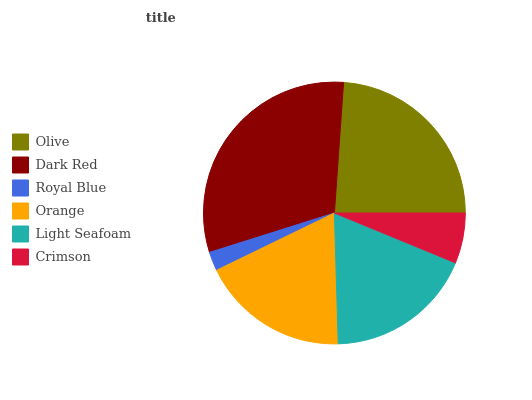Is Royal Blue the minimum?
Answer yes or no. Yes. Is Dark Red the maximum?
Answer yes or no. Yes. Is Dark Red the minimum?
Answer yes or no. No. Is Royal Blue the maximum?
Answer yes or no. No. Is Dark Red greater than Royal Blue?
Answer yes or no. Yes. Is Royal Blue less than Dark Red?
Answer yes or no. Yes. Is Royal Blue greater than Dark Red?
Answer yes or no. No. Is Dark Red less than Royal Blue?
Answer yes or no. No. Is Light Seafoam the high median?
Answer yes or no. Yes. Is Orange the low median?
Answer yes or no. Yes. Is Royal Blue the high median?
Answer yes or no. No. Is Light Seafoam the low median?
Answer yes or no. No. 